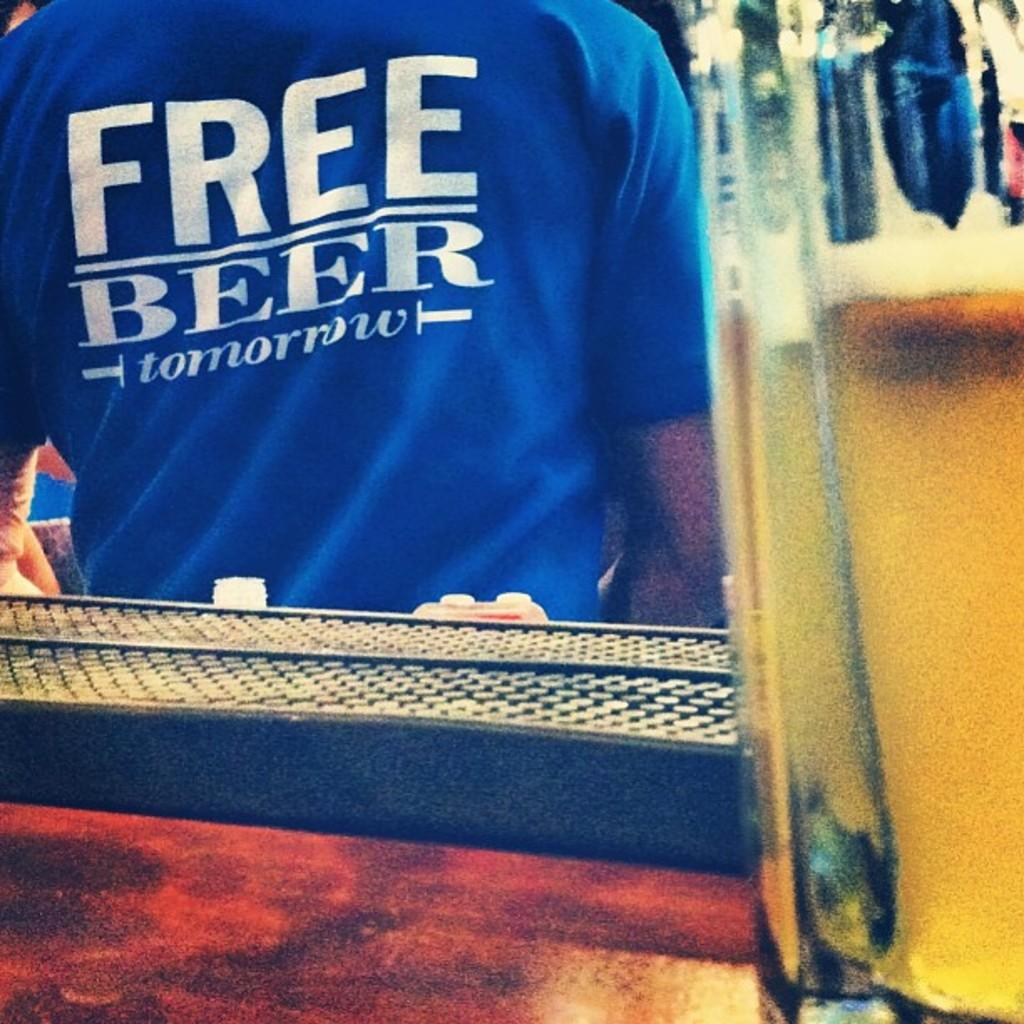Provide a one-sentence caption for the provided image. Bar including a man wearing a free beer t shirt. 